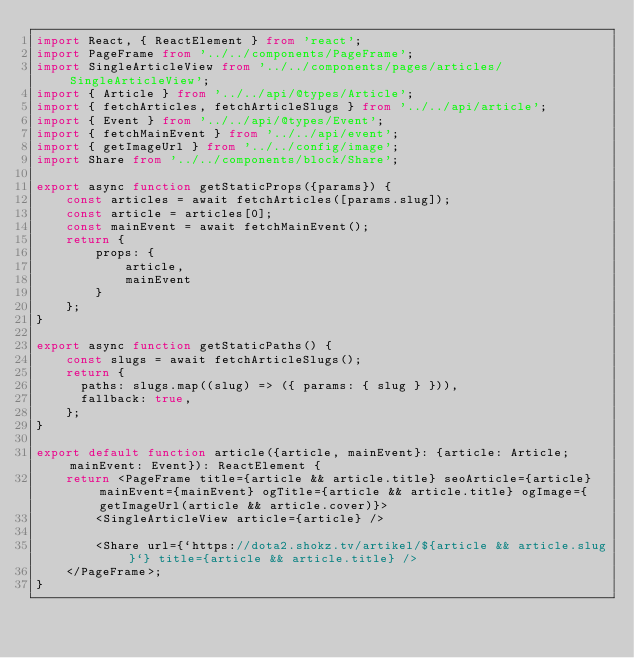Convert code to text. <code><loc_0><loc_0><loc_500><loc_500><_TypeScript_>import React, { ReactElement } from 'react';
import PageFrame from '../../components/PageFrame';
import SingleArticleView from '../../components/pages/articles/SingleArticleView';
import { Article } from '../../api/@types/Article';
import { fetchArticles, fetchArticleSlugs } from '../../api/article';
import { Event } from '../../api/@types/Event';
import { fetchMainEvent } from '../../api/event';
import { getImageUrl } from '../../config/image';
import Share from '../../components/block/Share';

export async function getStaticProps({params}) {
    const articles = await fetchArticles([params.slug]);
    const article = articles[0];
    const mainEvent = await fetchMainEvent();
    return {
        props: {
            article,
            mainEvent
        }
    };
}

export async function getStaticPaths() {
    const slugs = await fetchArticleSlugs();
    return {
      paths: slugs.map((slug) => ({ params: { slug } })),
      fallback: true,
    };
}

export default function article({article, mainEvent}: {article: Article; mainEvent: Event}): ReactElement {
    return <PageFrame title={article && article.title} seoArticle={article} mainEvent={mainEvent} ogTitle={article && article.title} ogImage={getImageUrl(article && article.cover)}>
        <SingleArticleView article={article} />

        <Share url={`https://dota2.shokz.tv/artikel/${article && article.slug}`} title={article && article.title} />
    </PageFrame>;
}</code> 